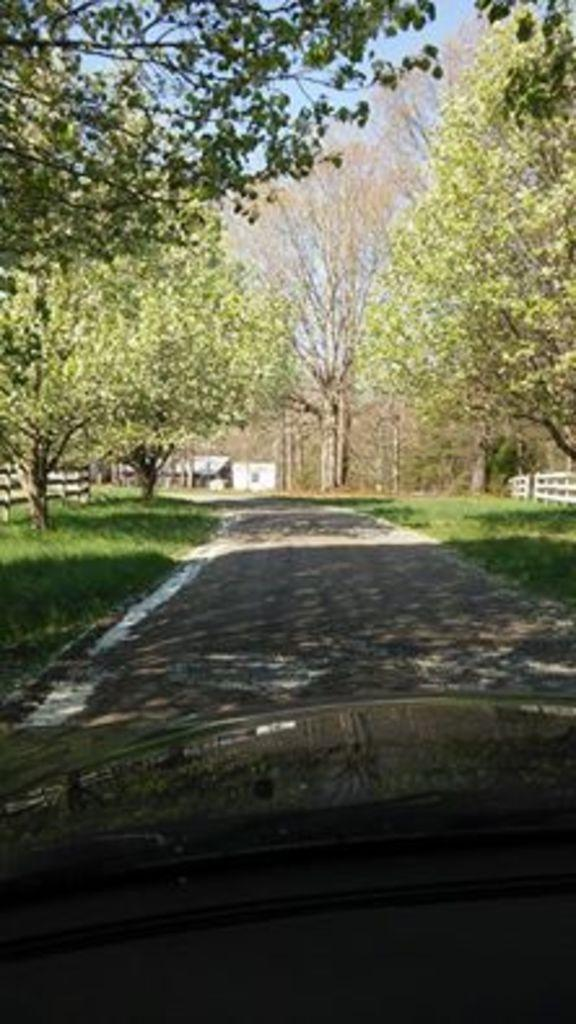What type of vegetation can be seen in the image? There are trees in the image. What else can be seen on the ground in the image? There is grass in the image. What type of man-made structure is present in the image? There is a road in the image. What can be seen in the background of the image? There is a fence and the sky visible in the background of the image. How many pies are being baked in the image? There are no pies or baking activity present in the image. What type of development can be seen in the image? There is no development or construction activity present in the image; it features natural elements like trees, grass, and a fence. 